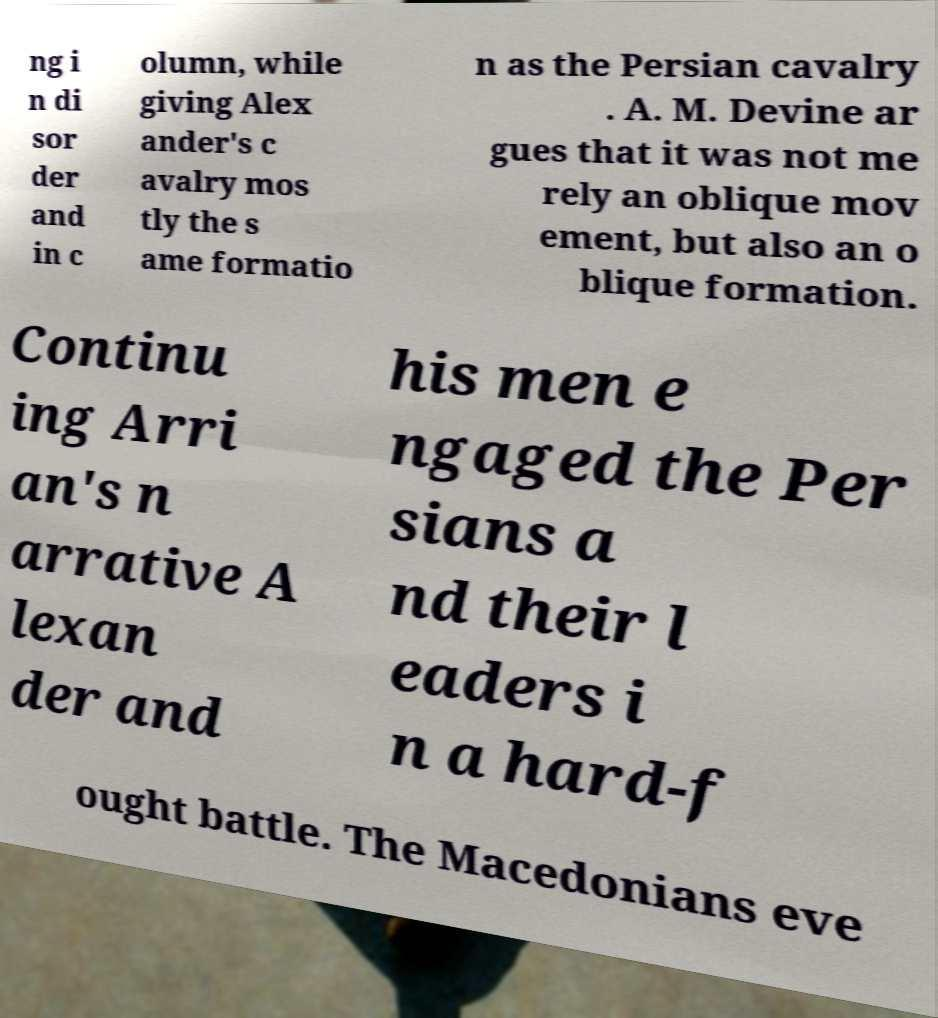Can you read and provide the text displayed in the image?This photo seems to have some interesting text. Can you extract and type it out for me? ng i n di sor der and in c olumn, while giving Alex ander's c avalry mos tly the s ame formatio n as the Persian cavalry . A. M. Devine ar gues that it was not me rely an oblique mov ement, but also an o blique formation. Continu ing Arri an's n arrative A lexan der and his men e ngaged the Per sians a nd their l eaders i n a hard-f ought battle. The Macedonians eve 